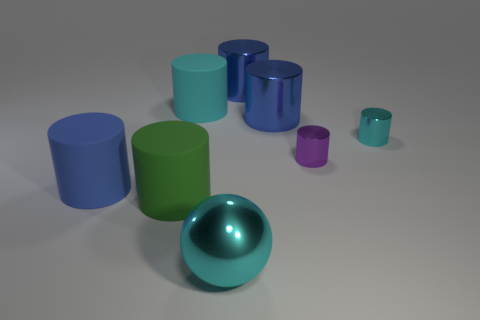What is the size relation between these objects? The objects vary in size; the sphere is the largest single object present. The green cylinder is slightly taller but narrower than the largest blue and cyan cylinders. The medium-sized cyan cylinders are of the same height but vary in diameter. The purple cylinder is the smallest in terms of both height and diameter. 